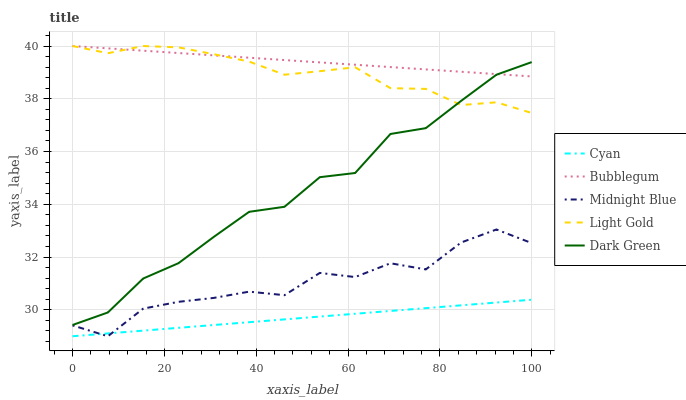Does Cyan have the minimum area under the curve?
Answer yes or no. Yes. Does Bubblegum have the maximum area under the curve?
Answer yes or no. Yes. Does Light Gold have the minimum area under the curve?
Answer yes or no. No. Does Light Gold have the maximum area under the curve?
Answer yes or no. No. Is Cyan the smoothest?
Answer yes or no. Yes. Is Midnight Blue the roughest?
Answer yes or no. Yes. Is Light Gold the smoothest?
Answer yes or no. No. Is Light Gold the roughest?
Answer yes or no. No. Does Cyan have the lowest value?
Answer yes or no. Yes. Does Light Gold have the lowest value?
Answer yes or no. No. Does Bubblegum have the highest value?
Answer yes or no. Yes. Does Midnight Blue have the highest value?
Answer yes or no. No. Is Cyan less than Bubblegum?
Answer yes or no. Yes. Is Light Gold greater than Midnight Blue?
Answer yes or no. Yes. Does Dark Green intersect Bubblegum?
Answer yes or no. Yes. Is Dark Green less than Bubblegum?
Answer yes or no. No. Is Dark Green greater than Bubblegum?
Answer yes or no. No. Does Cyan intersect Bubblegum?
Answer yes or no. No. 